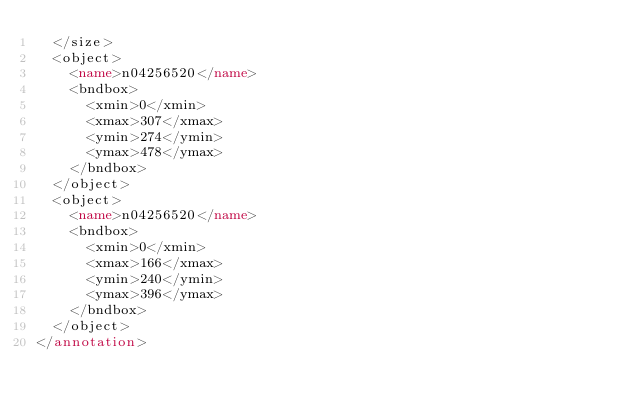Convert code to text. <code><loc_0><loc_0><loc_500><loc_500><_XML_>	</size>
	<object>
		<name>n04256520</name>
		<bndbox>
			<xmin>0</xmin>
			<xmax>307</xmax>
			<ymin>274</ymin>
			<ymax>478</ymax>
		</bndbox>
	</object>
	<object>
		<name>n04256520</name>
		<bndbox>
			<xmin>0</xmin>
			<xmax>166</xmax>
			<ymin>240</ymin>
			<ymax>396</ymax>
		</bndbox>
	</object>
</annotation>
</code> 